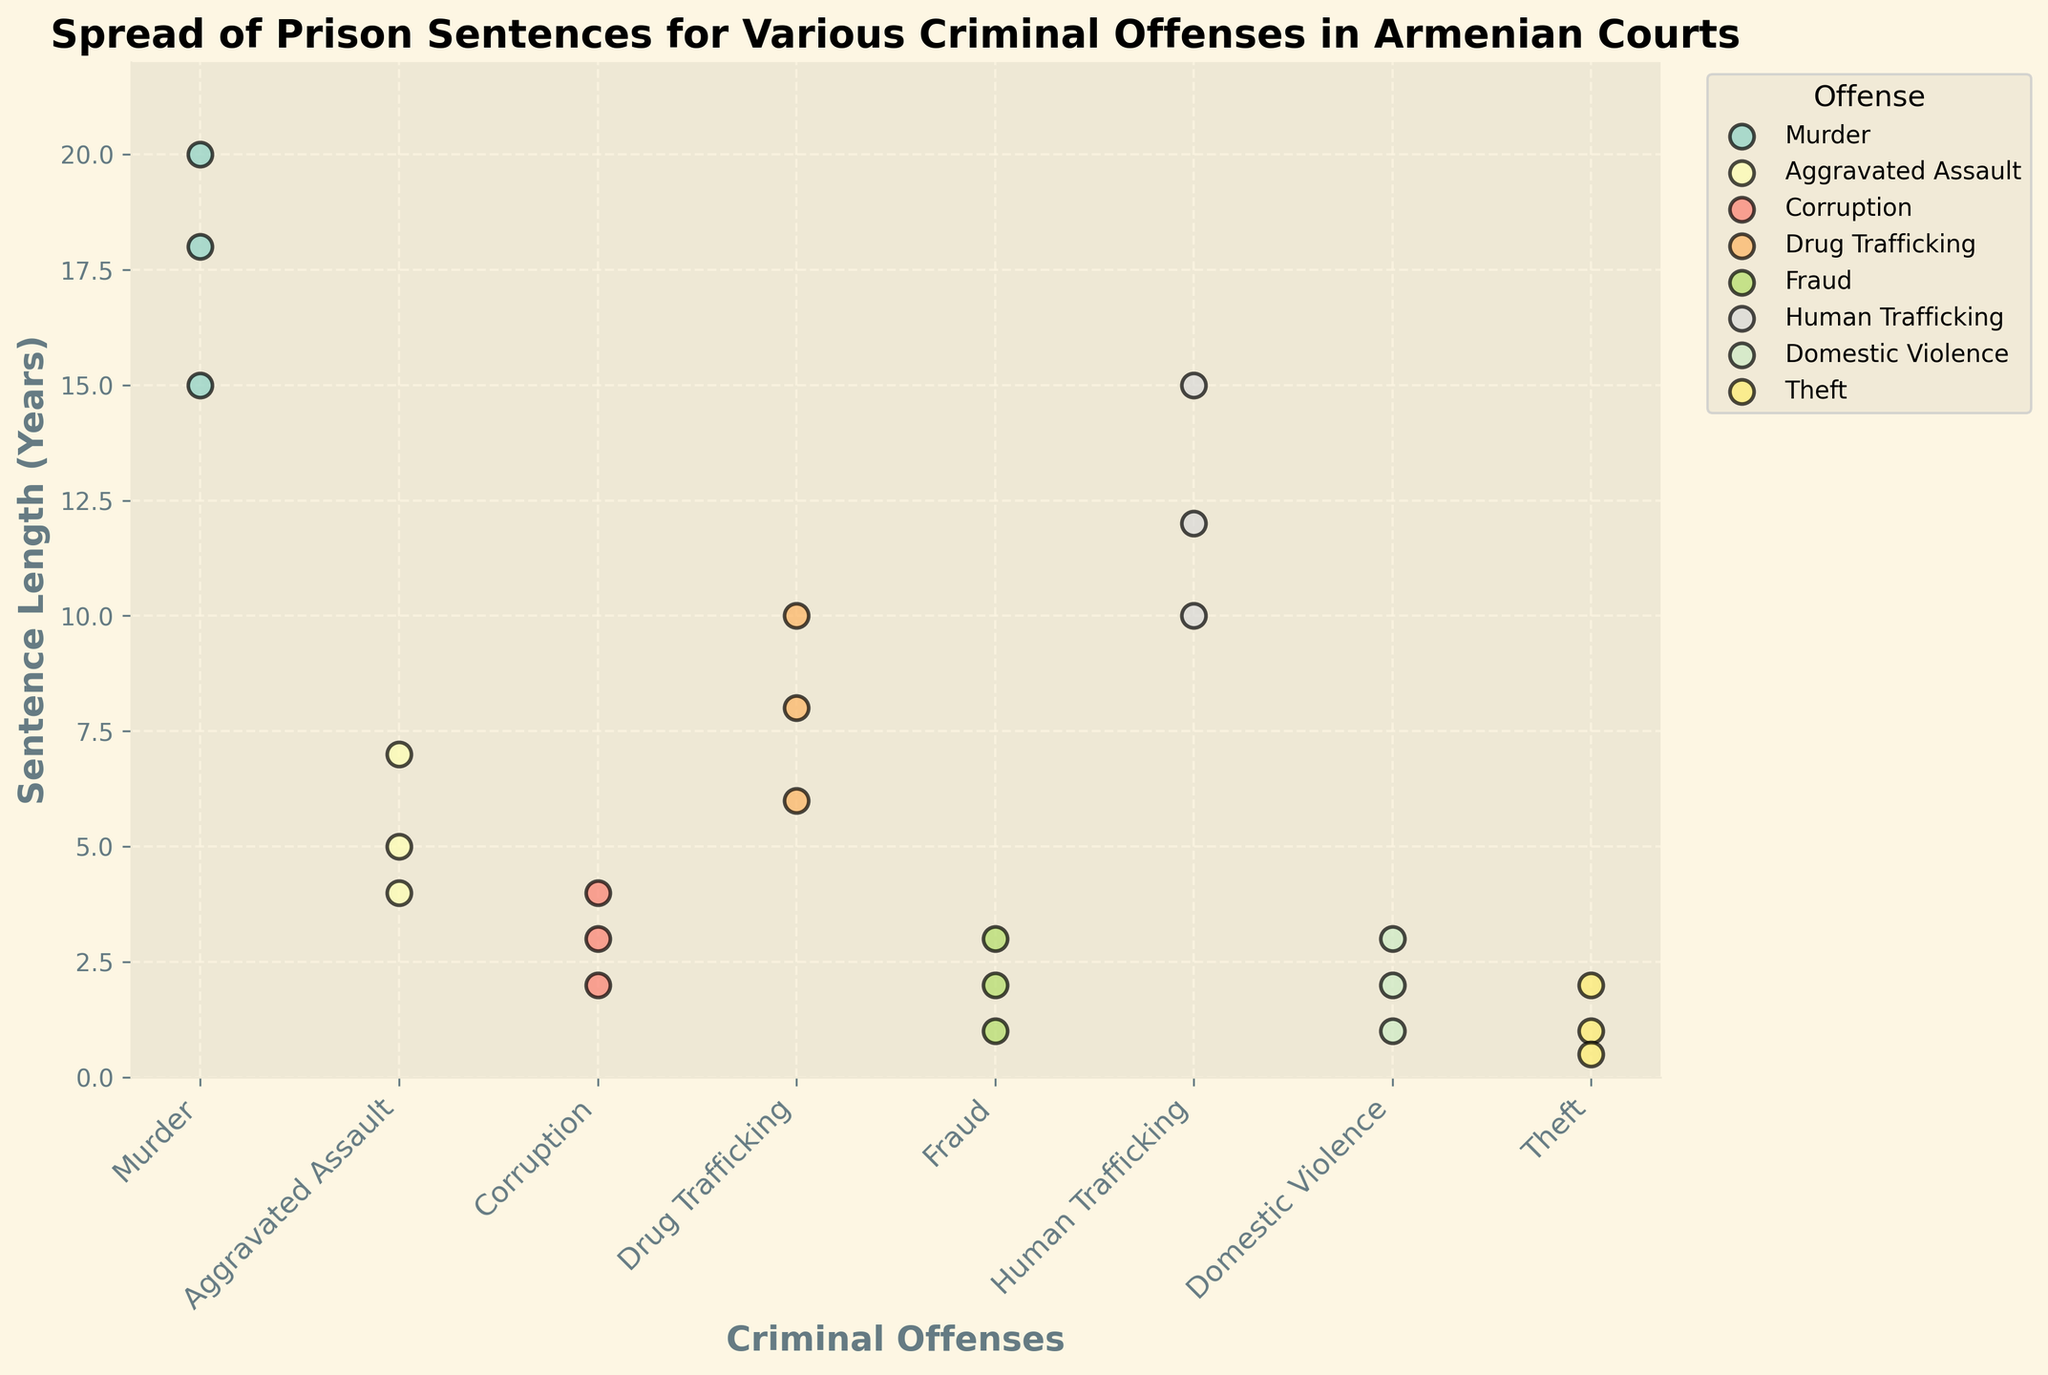What is the title of the figure? The title is displayed at the top of the figure. It reads: "Spread of Prison Sentences for Various Criminal Offenses in Armenian Courts"
Answer: Spread of Prison Sentences for Various Criminal Offenses in Armenian Courts What is the range of sentence lengths for the offense "Murder"? To determine the range, look at the minimum and maximum sentence lengths for the offense "Murder" in the plot. The multiple points for "Murder" range from 15 to 20 years.
Answer: 15 to 20 years Which criminal offense has the shortest sentence length displayed in the plot? The plot shows various points for different offenses. The smallest value can be identified visually. For example, the point for "Theft" has the shortest sentence length at 0.5 years.
Answer: Theft What is the mean sentence length for "Drug Trafficking"? To find the mean, add up all the sentence lengths for "Drug Trafficking" and divide by the number of data points. The lengths are 8, 10, and 6 years. Mean = (8+10+6) / 3 = 24 / 3 = 8 years.
Answer: 8 years Compare the median sentence length of "Fraud" and "Domestic Violence." Which offense has a higher median sentence length? To find the median, arrange the sentence lengths in order and select the middle value. For "Fraud," the sentences are 1, 2, and 3 years, with a median of 2 years. For "Domestic Violence," the sentences are 1, 2, and 3 years, with a median of 2 years. Both offenses have the same median sentence length.
Answer: Same median What is the difference between the longest sentences for "Corruption" and "Aggravated Assault"? Locate the longest sentences for both offenses. The longest for "Corruption" is 4 years, and for "Aggravated Assault," it is 7 years. The difference is 7 - 4 = 3 years.
Answer: 3 years Which offense has the most variable sentence lengths? Variability can be visually assessed by the spread of the points. "Murder" has significant variability ranging from 15 to 20 years, whereas other offenses have a smaller spread.
Answer: Murder How many offenses have a sentence length data point of exactly 3 years? Check the plot for scattered points at the value '3 years'. "Fraud," "Corruption," and "Domestic Violence" each have one point at 3 years.
Answer: 3 offenses Compare the sentence length range between "Human Trafficking" and "Drug Trafficking". Which has a wider range? For "Human Trafficking," the range is 10 to 15 years (15-10=5 years). For "Drug Trafficking," the range is 6 to 10 years (10-6=4 years). "Human Trafficking" has a wider range.
Answer: Human Trafficking Which offenses have their minimum sentence lengths below 5 years? By examining the plot, identify offenses where the minimum sentence length is below 5 years. Offenses like "Corruption," "Domestic Violence," "Fraud," and "Theft" all have minimum lengths below 5 years.
Answer: Corruption, Domestic Violence, Fraud, Theft 